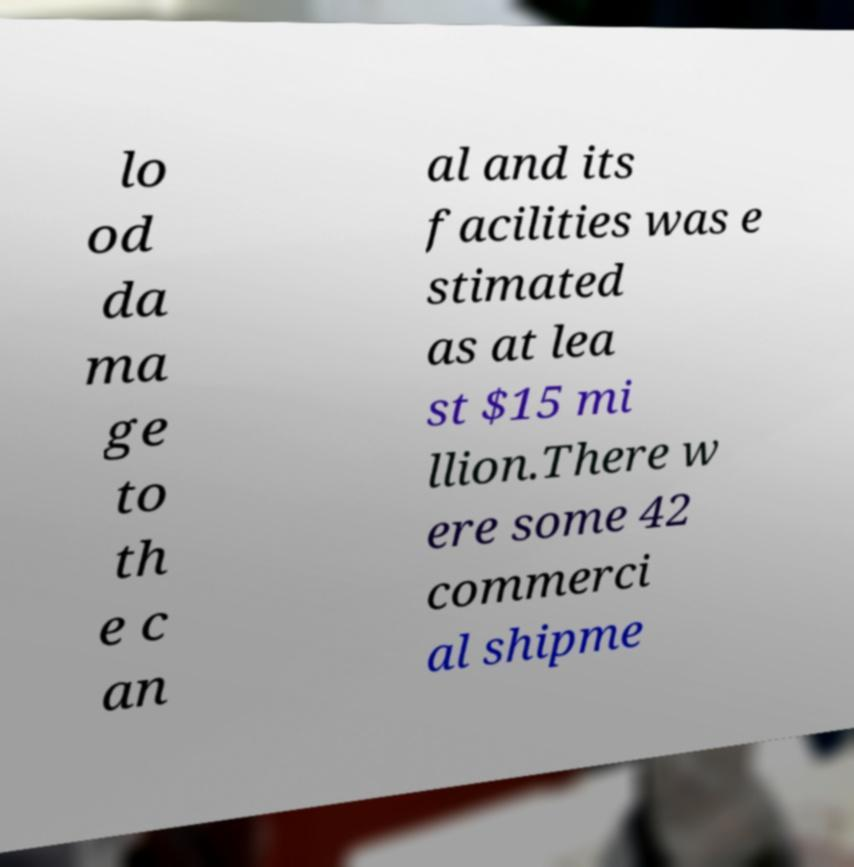Please read and relay the text visible in this image. What does it say? lo od da ma ge to th e c an al and its facilities was e stimated as at lea st $15 mi llion.There w ere some 42 commerci al shipme 